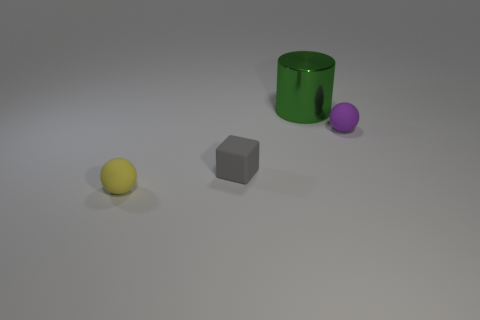Add 3 red matte cylinders. How many objects exist? 7 Subtract all cubes. How many objects are left? 3 Subtract all yellow rubber spheres. Subtract all yellow matte things. How many objects are left? 2 Add 1 spheres. How many spheres are left? 3 Add 1 yellow matte things. How many yellow matte things exist? 2 Subtract 0 cyan cylinders. How many objects are left? 4 